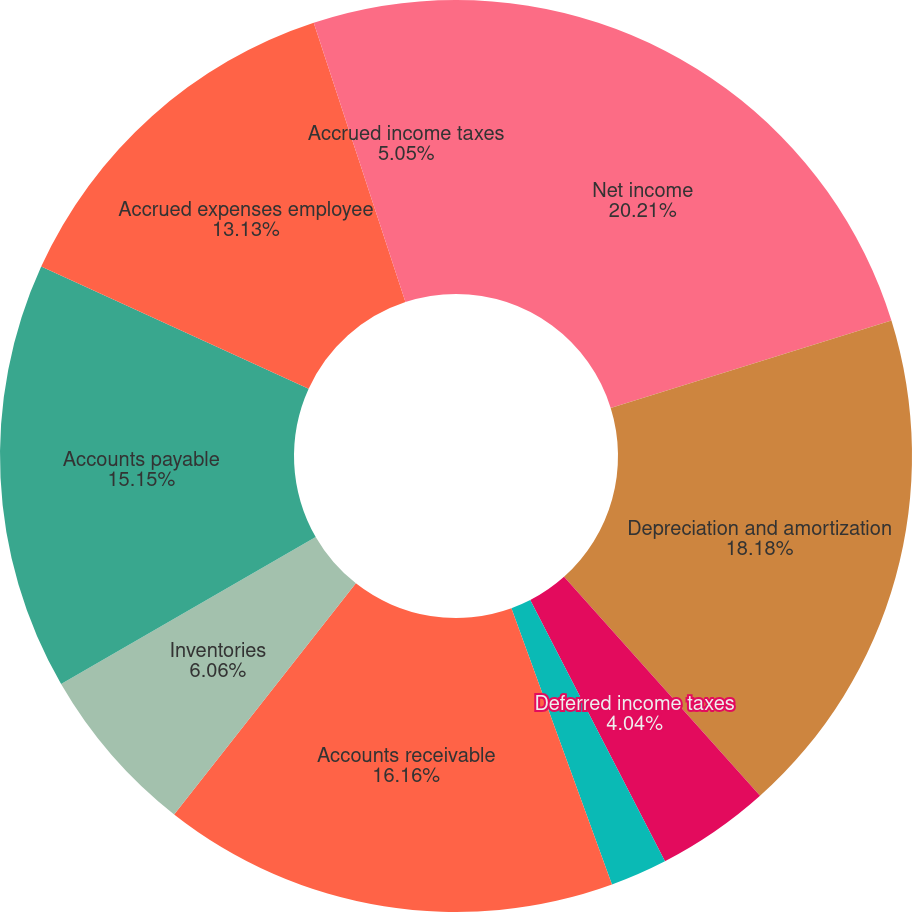Convert chart to OTSL. <chart><loc_0><loc_0><loc_500><loc_500><pie_chart><fcel>Net income<fcel>Depreciation and amortization<fcel>Stock-based compensation<fcel>Deferred income taxes<fcel>Other non-cash operating<fcel>Accounts receivable<fcel>Inventories<fcel>Accounts payable<fcel>Accrued expenses employee<fcel>Accrued income taxes<nl><fcel>20.2%<fcel>18.18%<fcel>0.0%<fcel>4.04%<fcel>2.02%<fcel>16.16%<fcel>6.06%<fcel>15.15%<fcel>13.13%<fcel>5.05%<nl></chart> 